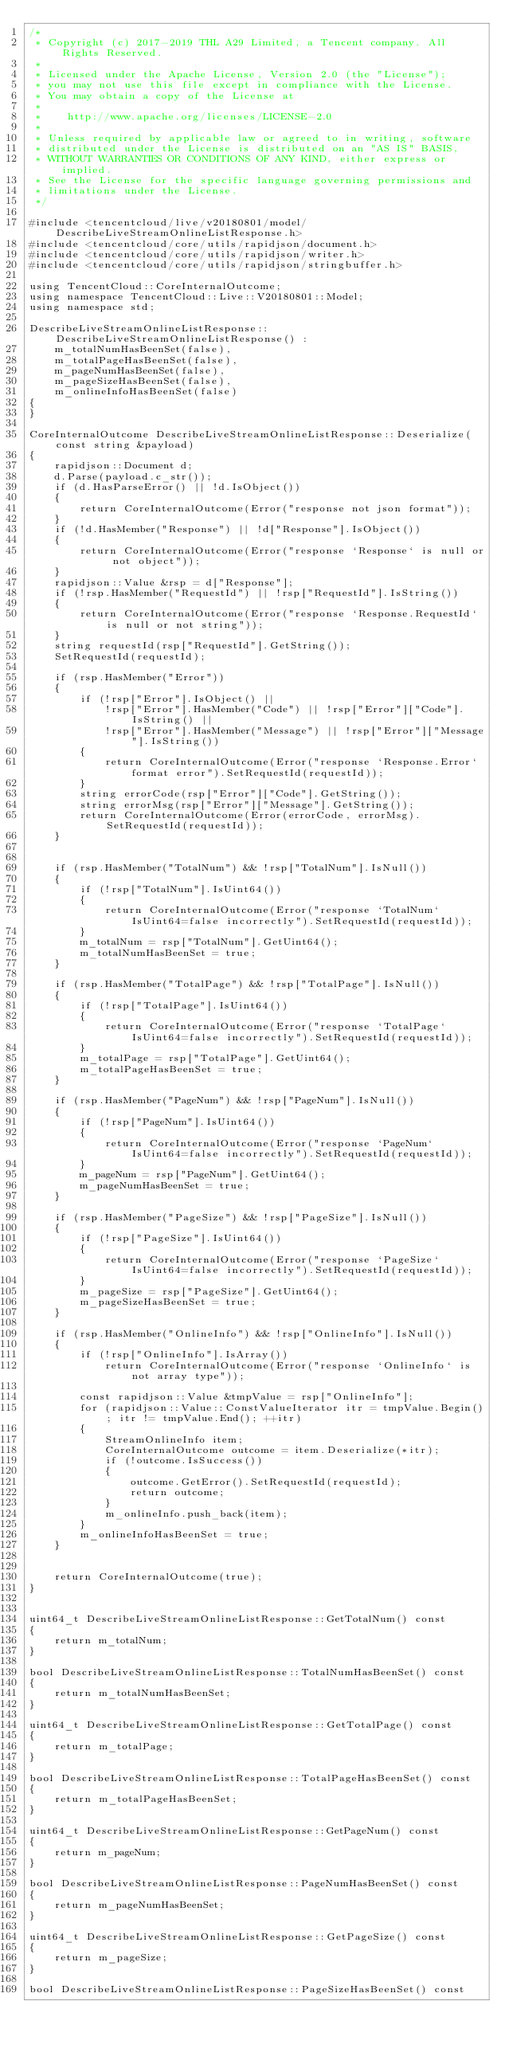<code> <loc_0><loc_0><loc_500><loc_500><_C++_>/*
 * Copyright (c) 2017-2019 THL A29 Limited, a Tencent company. All Rights Reserved.
 *
 * Licensed under the Apache License, Version 2.0 (the "License");
 * you may not use this file except in compliance with the License.
 * You may obtain a copy of the License at
 *
 *    http://www.apache.org/licenses/LICENSE-2.0
 *
 * Unless required by applicable law or agreed to in writing, software
 * distributed under the License is distributed on an "AS IS" BASIS,
 * WITHOUT WARRANTIES OR CONDITIONS OF ANY KIND, either express or implied.
 * See the License for the specific language governing permissions and
 * limitations under the License.
 */

#include <tencentcloud/live/v20180801/model/DescribeLiveStreamOnlineListResponse.h>
#include <tencentcloud/core/utils/rapidjson/document.h>
#include <tencentcloud/core/utils/rapidjson/writer.h>
#include <tencentcloud/core/utils/rapidjson/stringbuffer.h>

using TencentCloud::CoreInternalOutcome;
using namespace TencentCloud::Live::V20180801::Model;
using namespace std;

DescribeLiveStreamOnlineListResponse::DescribeLiveStreamOnlineListResponse() :
    m_totalNumHasBeenSet(false),
    m_totalPageHasBeenSet(false),
    m_pageNumHasBeenSet(false),
    m_pageSizeHasBeenSet(false),
    m_onlineInfoHasBeenSet(false)
{
}

CoreInternalOutcome DescribeLiveStreamOnlineListResponse::Deserialize(const string &payload)
{
    rapidjson::Document d;
    d.Parse(payload.c_str());
    if (d.HasParseError() || !d.IsObject())
    {
        return CoreInternalOutcome(Error("response not json format"));
    }
    if (!d.HasMember("Response") || !d["Response"].IsObject())
    {
        return CoreInternalOutcome(Error("response `Response` is null or not object"));
    }
    rapidjson::Value &rsp = d["Response"];
    if (!rsp.HasMember("RequestId") || !rsp["RequestId"].IsString())
    {
        return CoreInternalOutcome(Error("response `Response.RequestId` is null or not string"));
    }
    string requestId(rsp["RequestId"].GetString());
    SetRequestId(requestId);

    if (rsp.HasMember("Error"))
    {
        if (!rsp["Error"].IsObject() ||
            !rsp["Error"].HasMember("Code") || !rsp["Error"]["Code"].IsString() ||
            !rsp["Error"].HasMember("Message") || !rsp["Error"]["Message"].IsString())
        {
            return CoreInternalOutcome(Error("response `Response.Error` format error").SetRequestId(requestId));
        }
        string errorCode(rsp["Error"]["Code"].GetString());
        string errorMsg(rsp["Error"]["Message"].GetString());
        return CoreInternalOutcome(Error(errorCode, errorMsg).SetRequestId(requestId));
    }


    if (rsp.HasMember("TotalNum") && !rsp["TotalNum"].IsNull())
    {
        if (!rsp["TotalNum"].IsUint64())
        {
            return CoreInternalOutcome(Error("response `TotalNum` IsUint64=false incorrectly").SetRequestId(requestId));
        }
        m_totalNum = rsp["TotalNum"].GetUint64();
        m_totalNumHasBeenSet = true;
    }

    if (rsp.HasMember("TotalPage") && !rsp["TotalPage"].IsNull())
    {
        if (!rsp["TotalPage"].IsUint64())
        {
            return CoreInternalOutcome(Error("response `TotalPage` IsUint64=false incorrectly").SetRequestId(requestId));
        }
        m_totalPage = rsp["TotalPage"].GetUint64();
        m_totalPageHasBeenSet = true;
    }

    if (rsp.HasMember("PageNum") && !rsp["PageNum"].IsNull())
    {
        if (!rsp["PageNum"].IsUint64())
        {
            return CoreInternalOutcome(Error("response `PageNum` IsUint64=false incorrectly").SetRequestId(requestId));
        }
        m_pageNum = rsp["PageNum"].GetUint64();
        m_pageNumHasBeenSet = true;
    }

    if (rsp.HasMember("PageSize") && !rsp["PageSize"].IsNull())
    {
        if (!rsp["PageSize"].IsUint64())
        {
            return CoreInternalOutcome(Error("response `PageSize` IsUint64=false incorrectly").SetRequestId(requestId));
        }
        m_pageSize = rsp["PageSize"].GetUint64();
        m_pageSizeHasBeenSet = true;
    }

    if (rsp.HasMember("OnlineInfo") && !rsp["OnlineInfo"].IsNull())
    {
        if (!rsp["OnlineInfo"].IsArray())
            return CoreInternalOutcome(Error("response `OnlineInfo` is not array type"));

        const rapidjson::Value &tmpValue = rsp["OnlineInfo"];
        for (rapidjson::Value::ConstValueIterator itr = tmpValue.Begin(); itr != tmpValue.End(); ++itr)
        {
            StreamOnlineInfo item;
            CoreInternalOutcome outcome = item.Deserialize(*itr);
            if (!outcome.IsSuccess())
            {
                outcome.GetError().SetRequestId(requestId);
                return outcome;
            }
            m_onlineInfo.push_back(item);
        }
        m_onlineInfoHasBeenSet = true;
    }


    return CoreInternalOutcome(true);
}


uint64_t DescribeLiveStreamOnlineListResponse::GetTotalNum() const
{
    return m_totalNum;
}

bool DescribeLiveStreamOnlineListResponse::TotalNumHasBeenSet() const
{
    return m_totalNumHasBeenSet;
}

uint64_t DescribeLiveStreamOnlineListResponse::GetTotalPage() const
{
    return m_totalPage;
}

bool DescribeLiveStreamOnlineListResponse::TotalPageHasBeenSet() const
{
    return m_totalPageHasBeenSet;
}

uint64_t DescribeLiveStreamOnlineListResponse::GetPageNum() const
{
    return m_pageNum;
}

bool DescribeLiveStreamOnlineListResponse::PageNumHasBeenSet() const
{
    return m_pageNumHasBeenSet;
}

uint64_t DescribeLiveStreamOnlineListResponse::GetPageSize() const
{
    return m_pageSize;
}

bool DescribeLiveStreamOnlineListResponse::PageSizeHasBeenSet() const</code> 